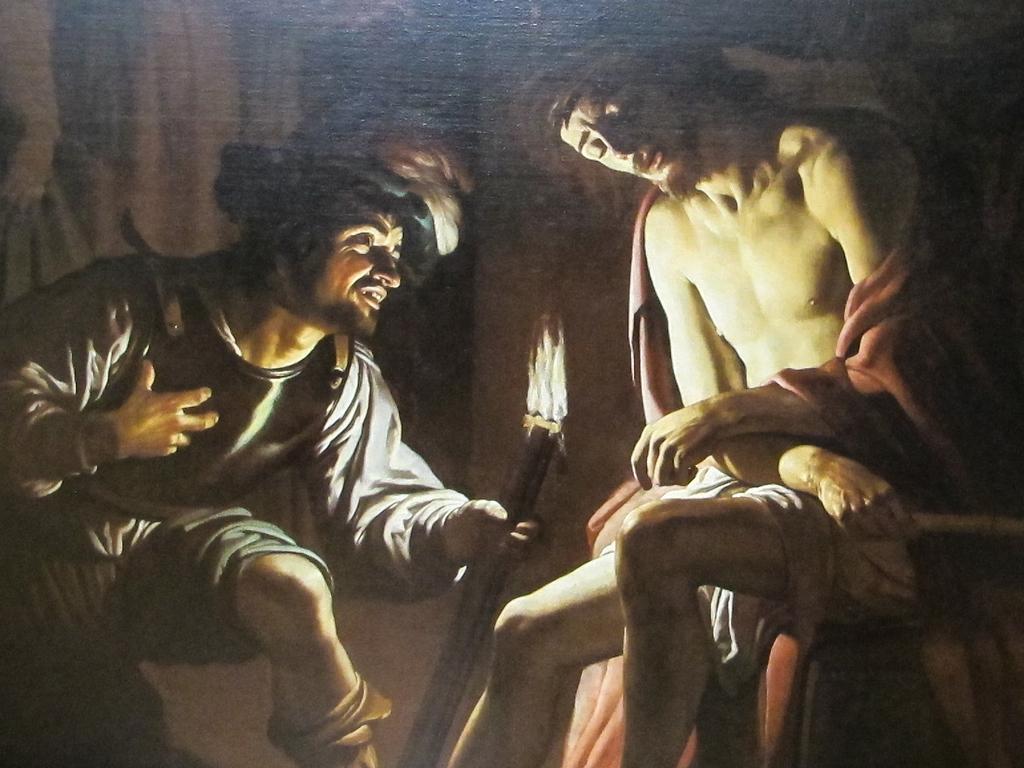Please provide a concise description of this image. In this image, It is a painting of a man sitting and another person holding a torch fire. 